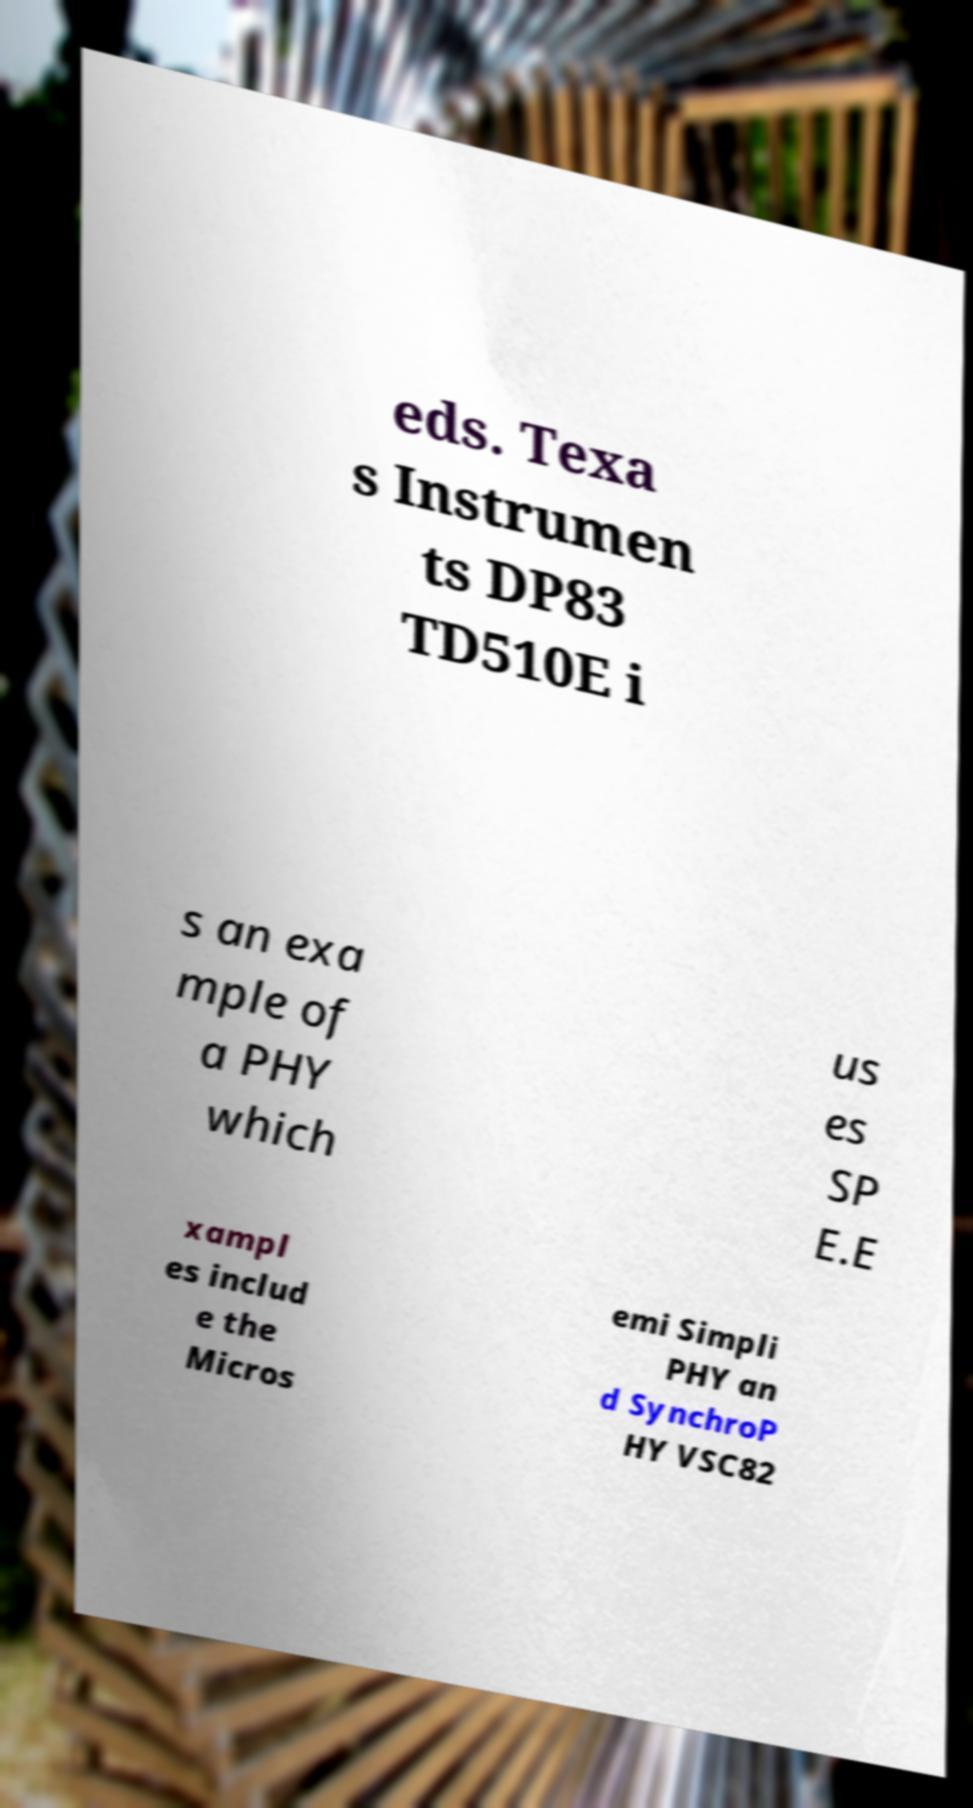What messages or text are displayed in this image? I need them in a readable, typed format. eds. Texa s Instrumen ts DP83 TD510E i s an exa mple of a PHY which us es SP E.E xampl es includ e the Micros emi Simpli PHY an d SynchroP HY VSC82 